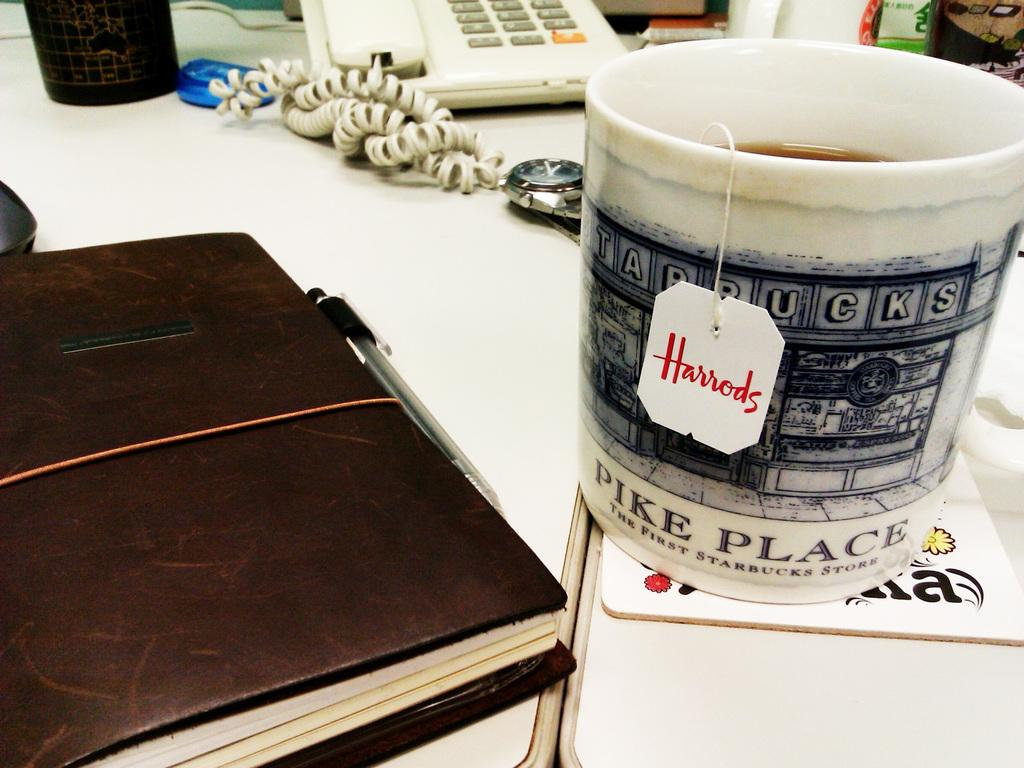<image>
Create a compact narrative representing the image presented. A Harrods tea bag in a Starbucks mug. 